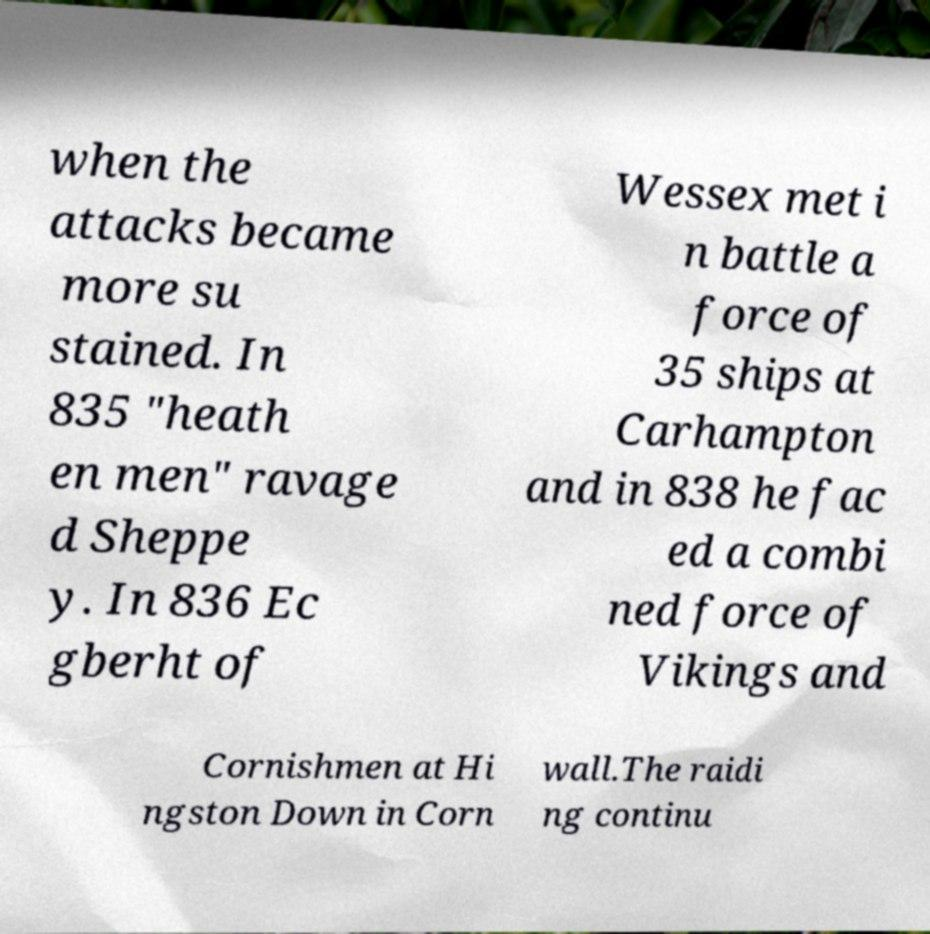Can you accurately transcribe the text from the provided image for me? when the attacks became more su stained. In 835 "heath en men" ravage d Sheppe y. In 836 Ec gberht of Wessex met i n battle a force of 35 ships at Carhampton and in 838 he fac ed a combi ned force of Vikings and Cornishmen at Hi ngston Down in Corn wall.The raidi ng continu 